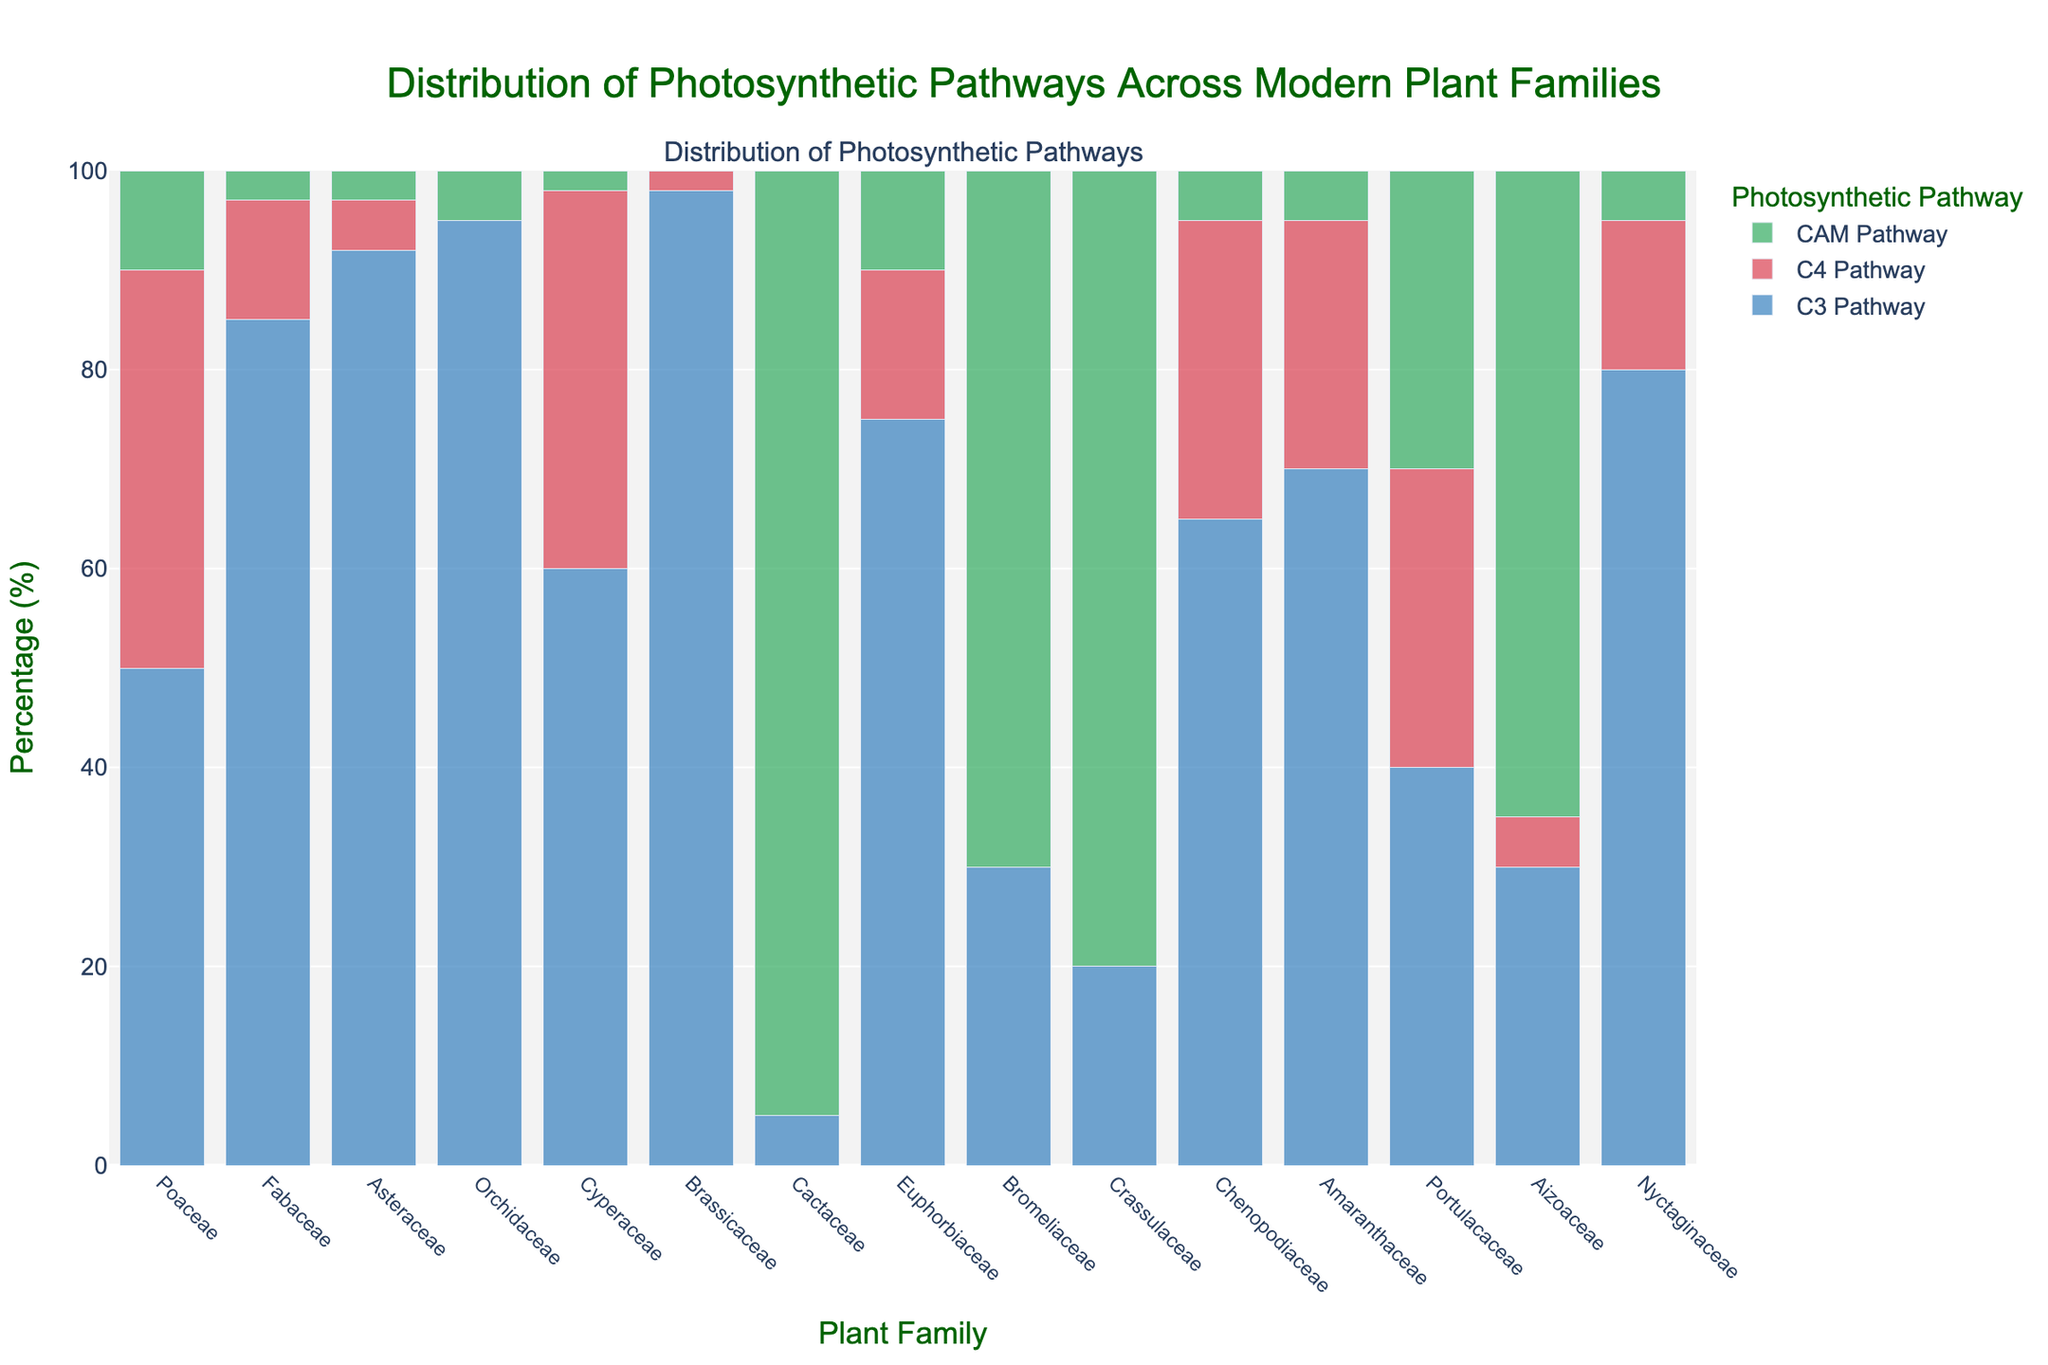Which plant family has the highest percentage of the CAM pathway? By observing the green bars in the figure, the family with the highest percentage of the CAM pathway is where the green bar is the tallest and reaches 95%. This is the Cactaceae family.
Answer: Cactaceae Which plant family has a greater percentage of the C4 pathway, Poaceae or Amaranthaceae? To determine this, we compare the height of the red bars for these families. Poaceae has a C4 percentage of 40%, and Amaranthaceae has a C4 percentage of 25%.
Answer: Poaceae What is the total percentage of plants using the CAM pathway across all listed families? Add up the given percentages for the CAM pathway in each family: 10 (Poaceae) + 3 (Fabaceae) + 3 (Asteraceae) + 5 (Orchidaceae) + 2 (Cyperaceae) + 0 (Brassicaceae) + 95 (Cactaceae) + 10 (Euphorbiaceae) + 70 (Bromeliaceae) + 80 (Crassulaceae) + 5 (Chenopodiaceae) + 5 (Amaranthaceae) + 30 (Portulacaceae) + 65 (Aizoaceae) + 5 (Nyctaginaceae) = 388%.
Answer: 388% Which plant family is represented by a blue, red, and green bar combination closest to an equal distribution of all pathways? We look for a family where the heights of the blue, red, and green bars are close to each other. Portulacaceae shows near equal distribution: 40% (C3), 30% (C4), and 30% (CAM).
Answer: Portulacaceae How many families have more than 50% of their plants using the C3 pathway? Count the families where the blue bar exceeds the 50% mark. These families are Poaceae, Fabaceae, Asteraceae, Orchidaceae, Cyperaceae, Brassicaceae, Euphorbiaceae, Chenopodiaceae, Amaranthaceae, Nyctaginaceae, making it 10 families.
Answer: 10 families Is there any plant family with no C4 or CAM pathways? We check each family for the complete absence of red and green bars. Orchidaceae only has a blue bar, with 95% in the C3 pathway.
Answer: Orchidaceae What percentage of the Aizoaceae family uses the C3 pathway? Refer to the height of the blue bar for the Aizoaceae family, which reaches 30%.
Answer: 30% Which two families have the highest disparity between C3 and C4 pathway percentages? Calculate the absolute difference between C3 and C4 percentages for each family: The largest differences are for Asteraceae (92% - 5% = 87%) and Brassicaceae (98% - 2% = 96%).
Answer: Brassicaceae and Asteraceae 